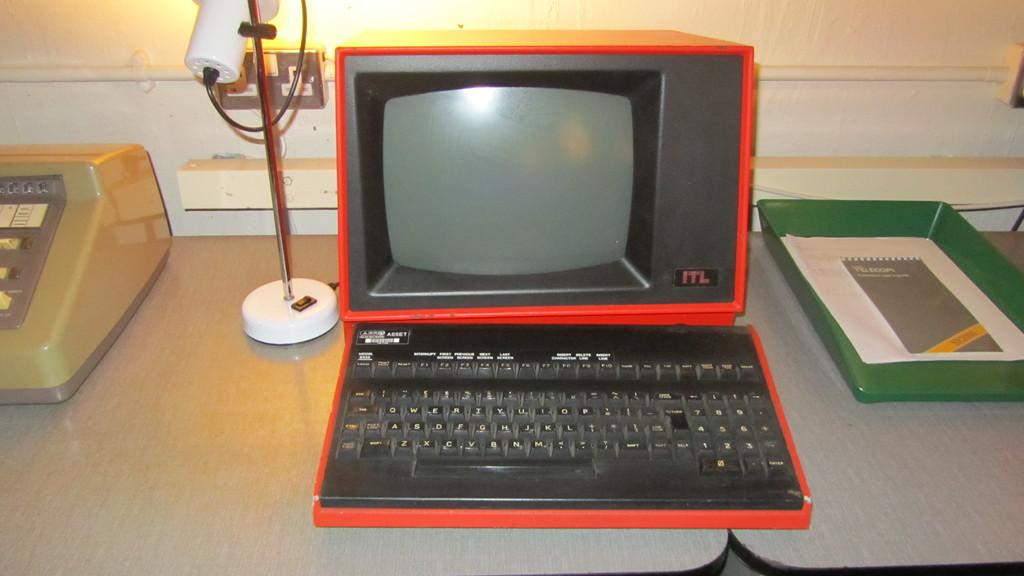What is the brand of the black and red device?
Offer a terse response. Itl. 